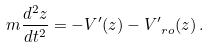<formula> <loc_0><loc_0><loc_500><loc_500>m \frac { d ^ { 2 } z } { d t ^ { 2 } } = - V ^ { \prime } ( z ) - V ^ { \prime } _ { \ r o } ( z ) \, .</formula> 